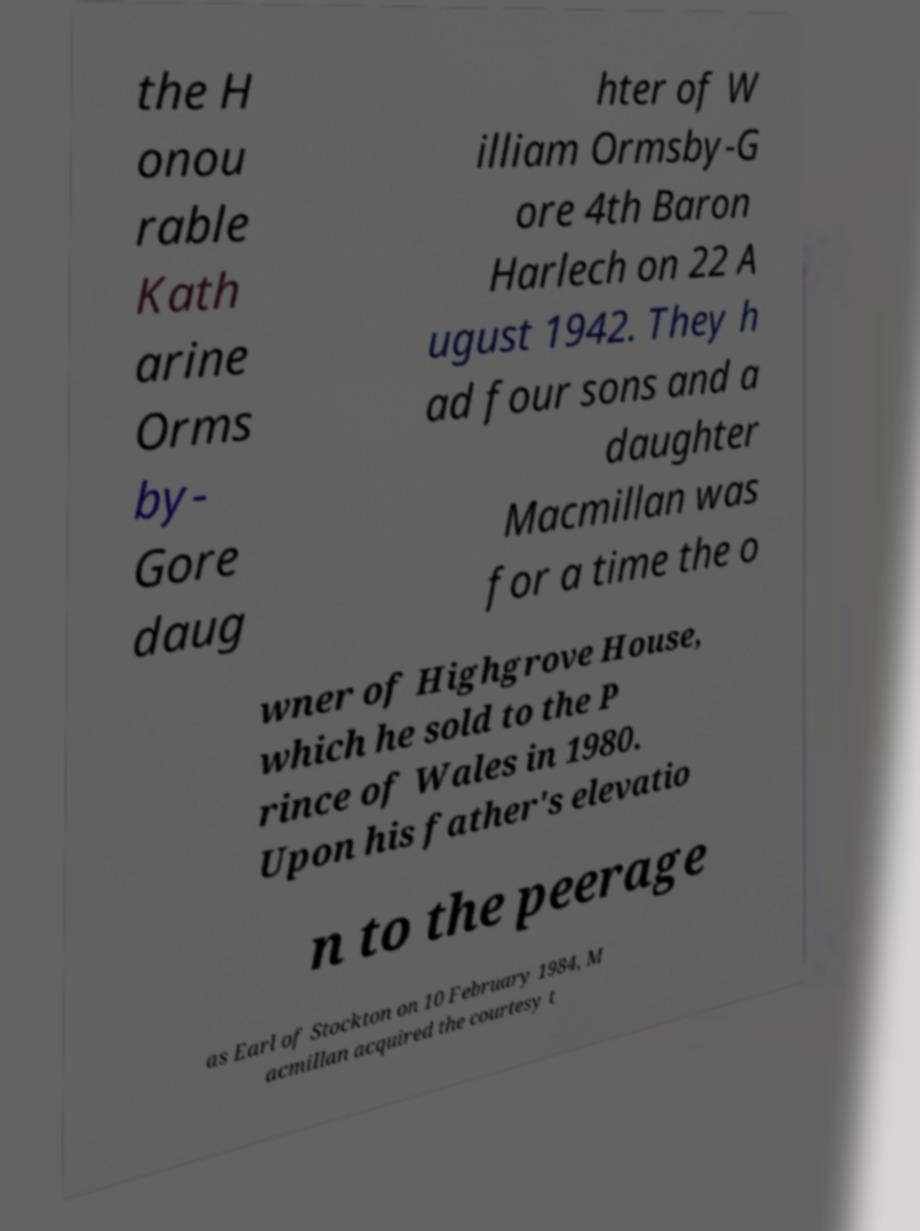Could you assist in decoding the text presented in this image and type it out clearly? the H onou rable Kath arine Orms by- Gore daug hter of W illiam Ormsby-G ore 4th Baron Harlech on 22 A ugust 1942. They h ad four sons and a daughter Macmillan was for a time the o wner of Highgrove House, which he sold to the P rince of Wales in 1980. Upon his father's elevatio n to the peerage as Earl of Stockton on 10 February 1984, M acmillan acquired the courtesy t 